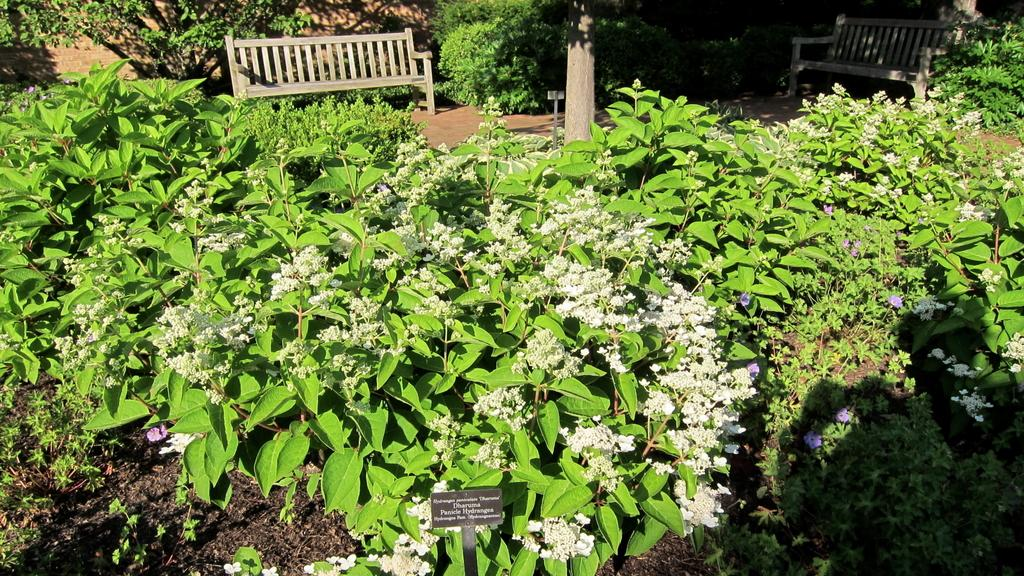What is the main object in the image? There is a name board in the image. What type of plants can be seen in the image? There are plants with flowers in the image. What can people sit on in the image? There are benches on the ground in the image. What is visible in the background of the image? There are trees visible in the background of the image. Can you see any cherries on the name board in the image? There are no cherries present on the name board or anywhere else in the image. 